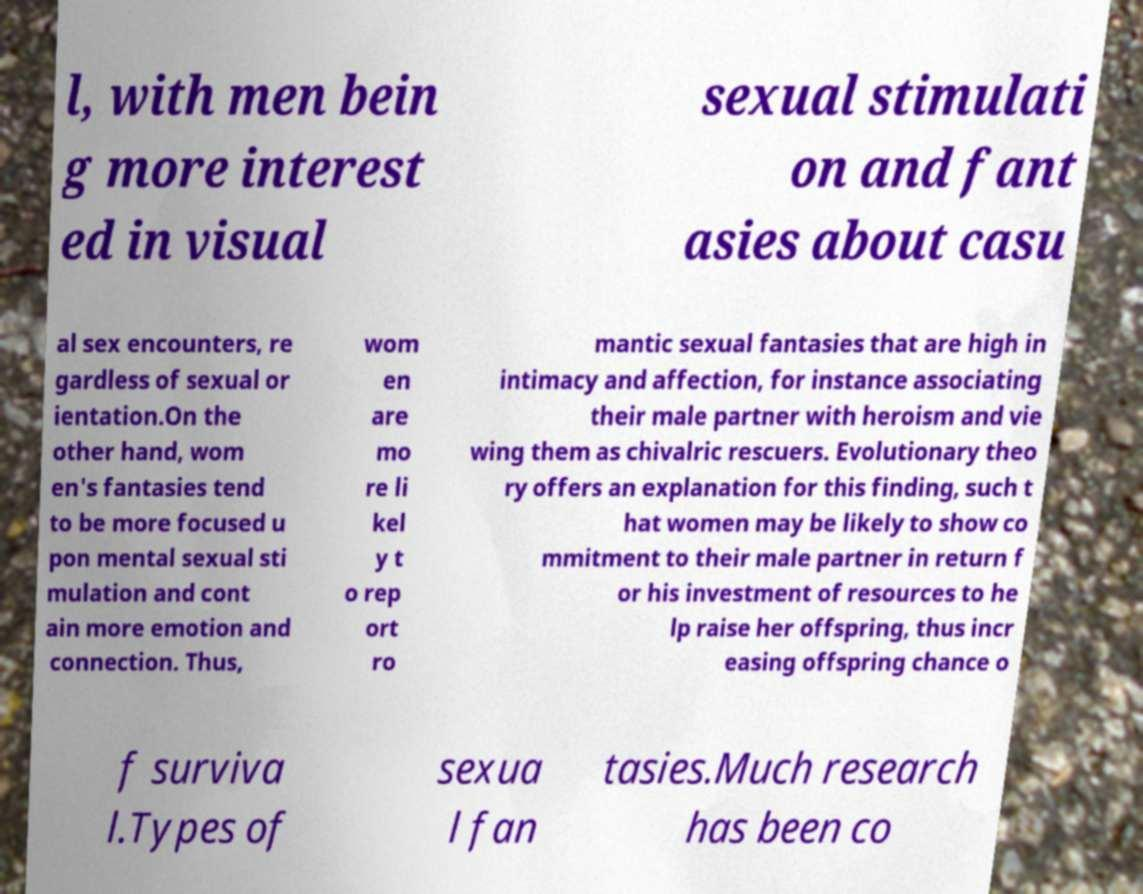I need the written content from this picture converted into text. Can you do that? l, with men bein g more interest ed in visual sexual stimulati on and fant asies about casu al sex encounters, re gardless of sexual or ientation.On the other hand, wom en's fantasies tend to be more focused u pon mental sexual sti mulation and cont ain more emotion and connection. Thus, wom en are mo re li kel y t o rep ort ro mantic sexual fantasies that are high in intimacy and affection, for instance associating their male partner with heroism and vie wing them as chivalric rescuers. Evolutionary theo ry offers an explanation for this finding, such t hat women may be likely to show co mmitment to their male partner in return f or his investment of resources to he lp raise her offspring, thus incr easing offspring chance o f surviva l.Types of sexua l fan tasies.Much research has been co 